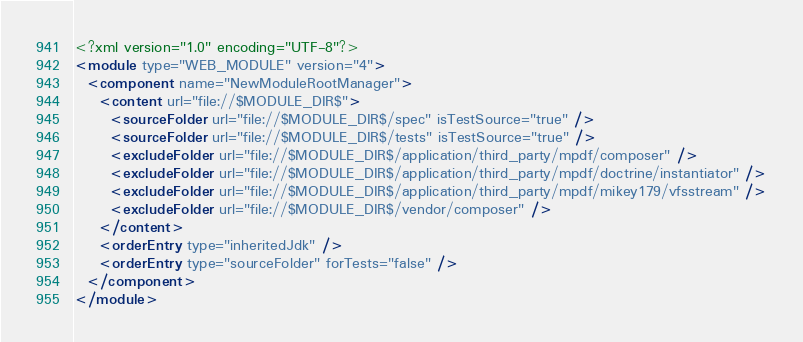Convert code to text. <code><loc_0><loc_0><loc_500><loc_500><_XML_><?xml version="1.0" encoding="UTF-8"?>
<module type="WEB_MODULE" version="4">
  <component name="NewModuleRootManager">
    <content url="file://$MODULE_DIR$">
      <sourceFolder url="file://$MODULE_DIR$/spec" isTestSource="true" />
      <sourceFolder url="file://$MODULE_DIR$/tests" isTestSource="true" />
      <excludeFolder url="file://$MODULE_DIR$/application/third_party/mpdf/composer" />
      <excludeFolder url="file://$MODULE_DIR$/application/third_party/mpdf/doctrine/instantiator" />
      <excludeFolder url="file://$MODULE_DIR$/application/third_party/mpdf/mikey179/vfsstream" />
      <excludeFolder url="file://$MODULE_DIR$/vendor/composer" />
    </content>
    <orderEntry type="inheritedJdk" />
    <orderEntry type="sourceFolder" forTests="false" />
  </component>
</module></code> 